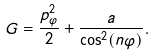<formula> <loc_0><loc_0><loc_500><loc_500>G = \frac { p _ { \varphi } ^ { 2 } } { 2 } + \frac { a } { \cos ^ { 2 } ( n \varphi ) } .</formula> 